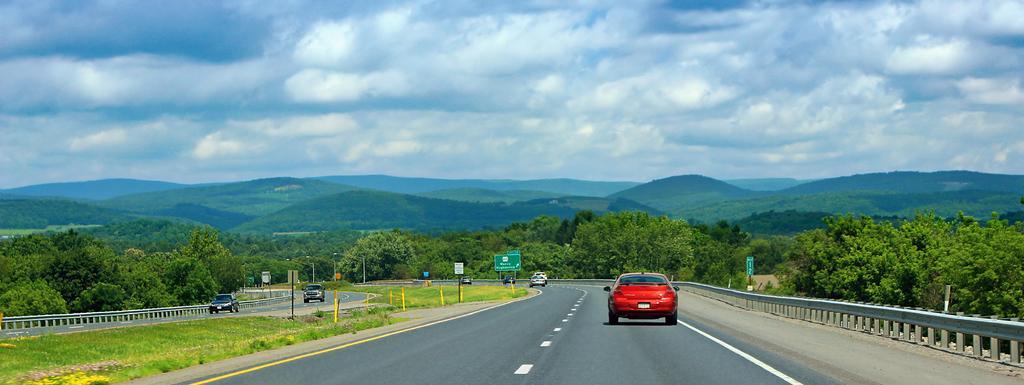Please provide a concise description of this image. In this image I can see some vehicles on the road. In the background, I can see the trees and clouds in the sky. 